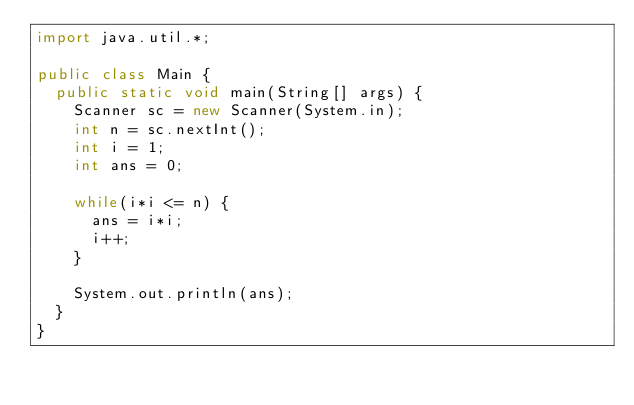Convert code to text. <code><loc_0><loc_0><loc_500><loc_500><_Java_>import java.util.*;

public class Main {
  public static void main(String[] args) {
    Scanner sc = new Scanner(System.in);
    int n = sc.nextInt();
    int i = 1;
    int ans = 0;
    
    while(i*i <= n) {
      ans = i*i;
      i++;
    }
        
    System.out.println(ans);
  }
}
</code> 